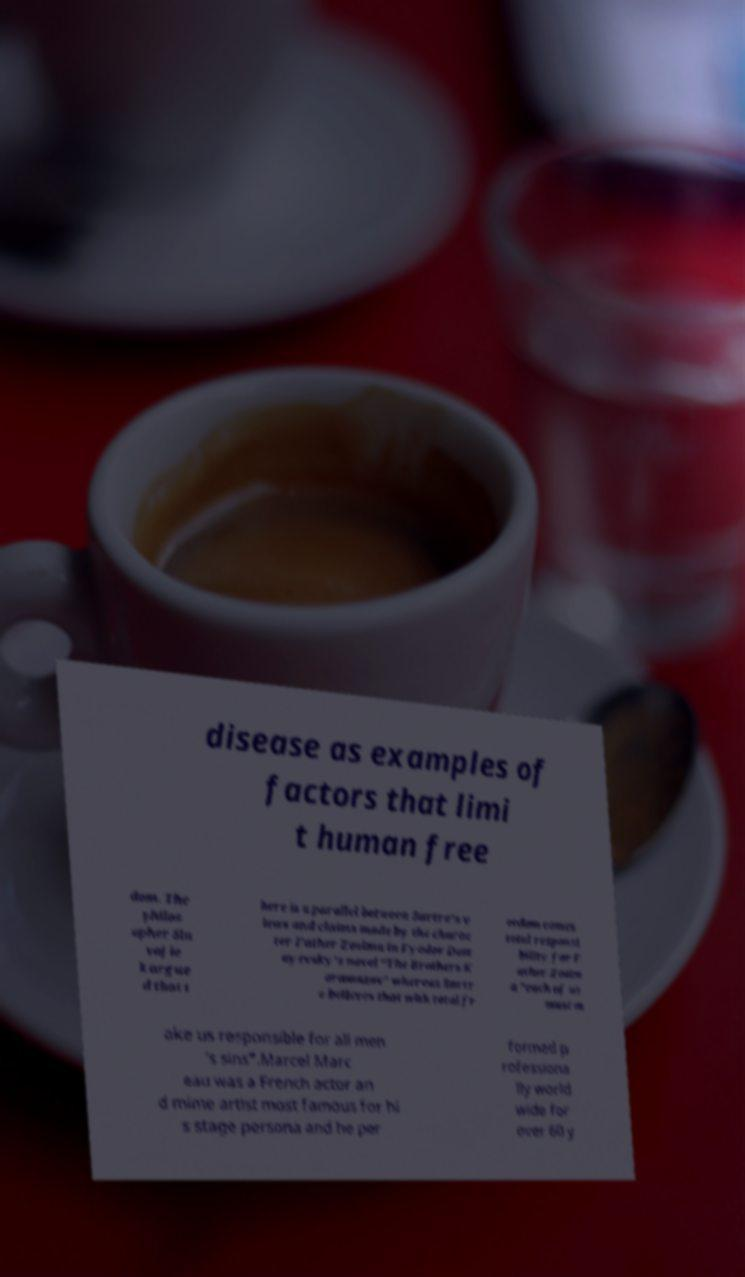Could you extract and type out the text from this image? disease as examples of factors that limi t human free dom. The philos opher Sla voj ie k argue d that t here is a parallel between Sartre's v iews and claims made by the charac ter Father Zosima in Fyodor Dost oyevsky's novel "The Brothers K aramazov" whereas Sartr e believes that with total fr eedom comes total responsi bility for F ather Zosim a "each of us must m ake us responsible for all men 's sins".Marcel Marc eau was a French actor an d mime artist most famous for hi s stage persona and he per formed p rofessiona lly world wide for over 60 y 